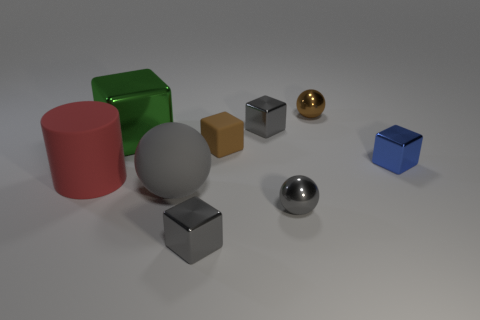Subtract 1 cubes. How many cubes are left? 4 Subtract all brown blocks. How many blocks are left? 4 Subtract all big green metal cubes. How many cubes are left? 4 Subtract all red blocks. Subtract all blue spheres. How many blocks are left? 5 Subtract all cylinders. How many objects are left? 8 Subtract 0 cyan cylinders. How many objects are left? 9 Subtract all big metal objects. Subtract all big cyan cubes. How many objects are left? 8 Add 5 big gray balls. How many big gray balls are left? 6 Add 7 large shiny things. How many large shiny things exist? 8 